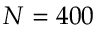<formula> <loc_0><loc_0><loc_500><loc_500>N = 4 0 0</formula> 